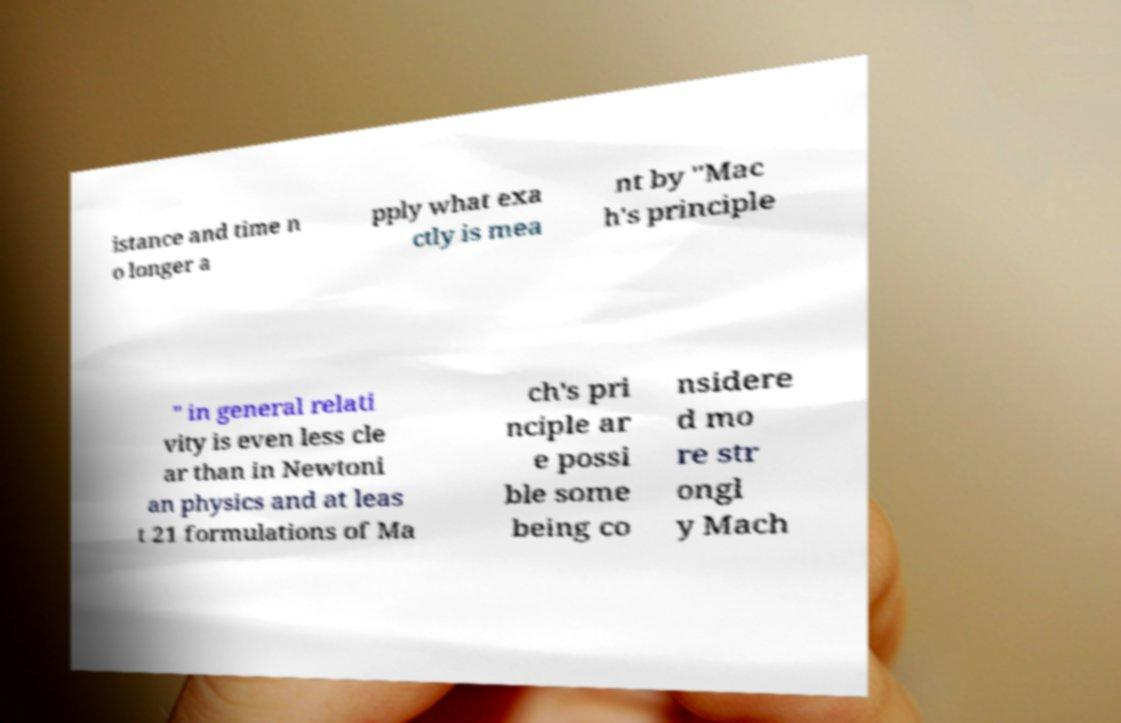Please read and relay the text visible in this image. What does it say? istance and time n o longer a pply what exa ctly is mea nt by "Mac h's principle " in general relati vity is even less cle ar than in Newtoni an physics and at leas t 21 formulations of Ma ch's pri nciple ar e possi ble some being co nsidere d mo re str ongl y Mach 